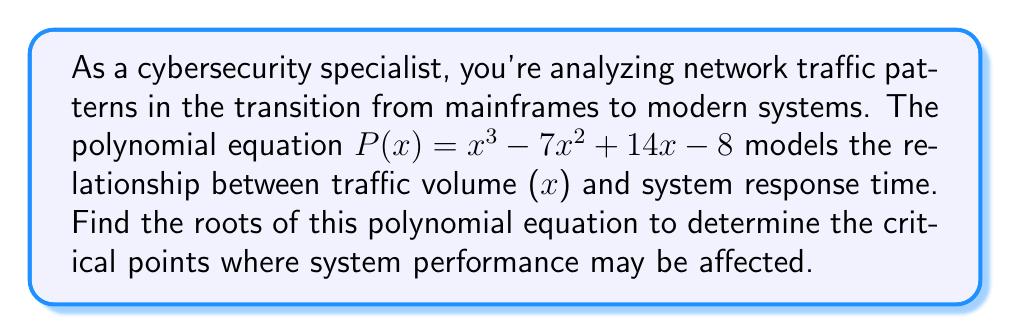Provide a solution to this math problem. To find the roots of the polynomial equation $P(x) = x^3 - 7x^2 + 14x - 8$, we need to factor it. Let's approach this step-by-step:

1) First, let's check if there are any rational roots using the rational root theorem. The possible rational roots are factors of the constant term (8): ±1, ±2, ±4, ±8.

2) Testing these values, we find that P(1) = 0. So, (x - 1) is a factor.

3) We can use polynomial long division to divide P(x) by (x - 1):

   $$\frac{x^3 - 7x^2 + 14x - 8}{x - 1} = x^2 - 6x + 8$$

4) So, $P(x) = (x - 1)(x^2 - 6x + 8)$

5) Now we need to factor $x^2 - 6x + 8$. We can use the quadratic formula or recognize it as a perfect square trinomial:

   $x^2 - 6x + 8 = (x - 4)(x - 2)$

6) Therefore, the fully factored polynomial is:

   $P(x) = (x - 1)(x - 2)(x - 4)$

7) The roots of the polynomial are the values that make each factor equal to zero:
   x = 1, x = 2, and x = 4

These roots represent the critical points in the network traffic model where system performance may be significantly affected during the transition from mainframes to modern systems.
Answer: The roots of the polynomial equation are x = 1, x = 2, and x = 4. 